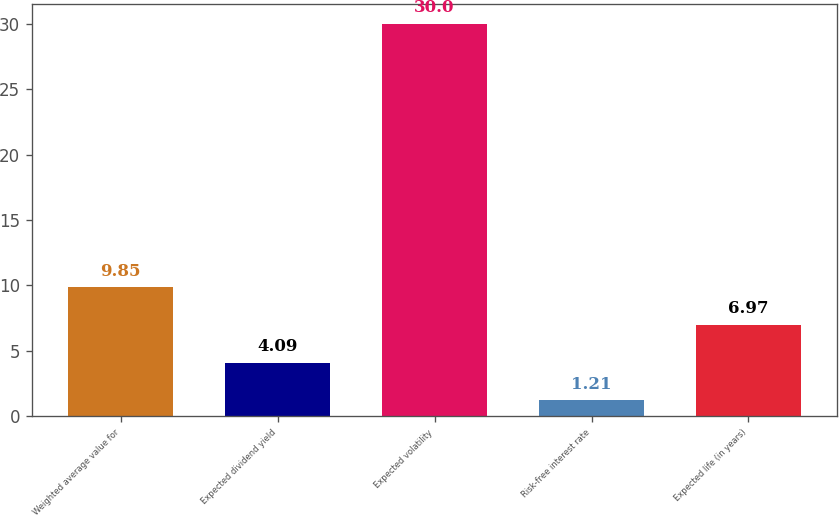Convert chart to OTSL. <chart><loc_0><loc_0><loc_500><loc_500><bar_chart><fcel>Weighted average value for<fcel>Expected dividend yield<fcel>Expected volatility<fcel>Risk-free interest rate<fcel>Expected life (in years)<nl><fcel>9.85<fcel>4.09<fcel>30<fcel>1.21<fcel>6.97<nl></chart> 